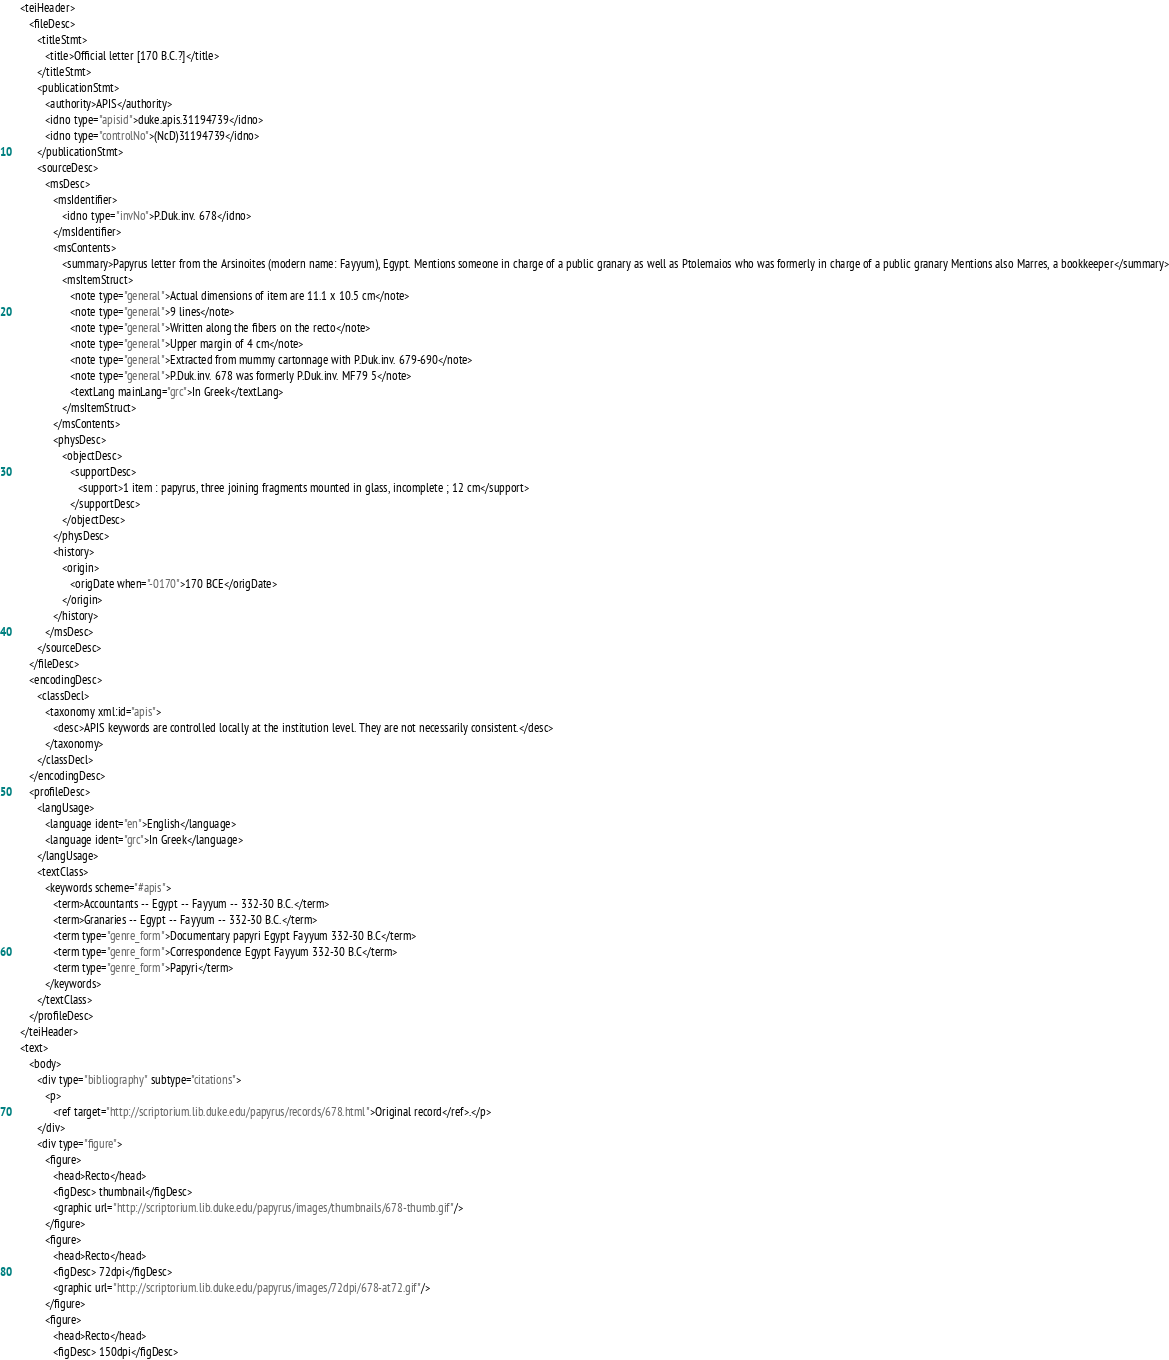<code> <loc_0><loc_0><loc_500><loc_500><_XML_>   <teiHeader>
      <fileDesc>
         <titleStmt>
            <title>Official letter [170 B.C.?]</title>
         </titleStmt>
         <publicationStmt>
            <authority>APIS</authority>
            <idno type="apisid">duke.apis.31194739</idno>
            <idno type="controlNo">(NcD)31194739</idno>
         </publicationStmt>
         <sourceDesc>
            <msDesc>
               <msIdentifier>
                  <idno type="invNo">P.Duk.inv. 678</idno>
               </msIdentifier>
               <msContents>
                  <summary>Papyrus letter from the Arsinoites (modern name: Fayyum), Egypt. Mentions someone in charge of a public granary as well as Ptolemaios who was formerly in charge of a public granary Mentions also Marres, a bookkeeper</summary>
                  <msItemStruct>
                     <note type="general">Actual dimensions of item are 11.1 x 10.5 cm</note>
                     <note type="general">9 lines</note>
                     <note type="general">Written along the fibers on the recto</note>
                     <note type="general">Upper margin of 4 cm</note>
                     <note type="general">Extracted from mummy cartonnage with P.Duk.inv. 679-690</note>
                     <note type="general">P.Duk.inv. 678 was formerly P.Duk.inv. MF79 5</note>
                     <textLang mainLang="grc">In Greek</textLang>
                  </msItemStruct>
               </msContents>
               <physDesc>
                  <objectDesc>
                     <supportDesc>
                        <support>1 item : papyrus, three joining fragments mounted in glass, incomplete ; 12 cm</support>
                     </supportDesc>
                  </objectDesc>
               </physDesc>
               <history>
                  <origin>
                     <origDate when="-0170">170 BCE</origDate>
                  </origin>
               </history>
            </msDesc>
         </sourceDesc>
      </fileDesc>
      <encodingDesc>
         <classDecl>
            <taxonomy xml:id="apis">
               <desc>APIS keywords are controlled locally at the institution level. They are not necessarily consistent.</desc>
            </taxonomy>
         </classDecl>
      </encodingDesc>
      <profileDesc>
         <langUsage>
            <language ident="en">English</language>
            <language ident="grc">In Greek</language>
         </langUsage>
         <textClass>
            <keywords scheme="#apis">
               <term>Accountants -- Egypt -- Fayyum -- 332-30 B.C.</term>
               <term>Granaries -- Egypt -- Fayyum -- 332-30 B.C.</term>
               <term type="genre_form">Documentary papyri Egypt Fayyum 332-30 B.C</term>
               <term type="genre_form">Correspondence Egypt Fayyum 332-30 B.C</term>
               <term type="genre_form">Papyri</term>
            </keywords>
         </textClass>
      </profileDesc>
   </teiHeader>
   <text>
      <body>
         <div type="bibliography" subtype="citations">
            <p>
               <ref target="http://scriptorium.lib.duke.edu/papyrus/records/678.html">Original record</ref>.</p>
         </div>
         <div type="figure">
            <figure>
               <head>Recto</head>
               <figDesc> thumbnail</figDesc>
               <graphic url="http://scriptorium.lib.duke.edu/papyrus/images/thumbnails/678-thumb.gif"/>
            </figure>
            <figure>
               <head>Recto</head>
               <figDesc> 72dpi</figDesc>
               <graphic url="http://scriptorium.lib.duke.edu/papyrus/images/72dpi/678-at72.gif"/>
            </figure>
            <figure>
               <head>Recto</head>
               <figDesc> 150dpi</figDesc></code> 